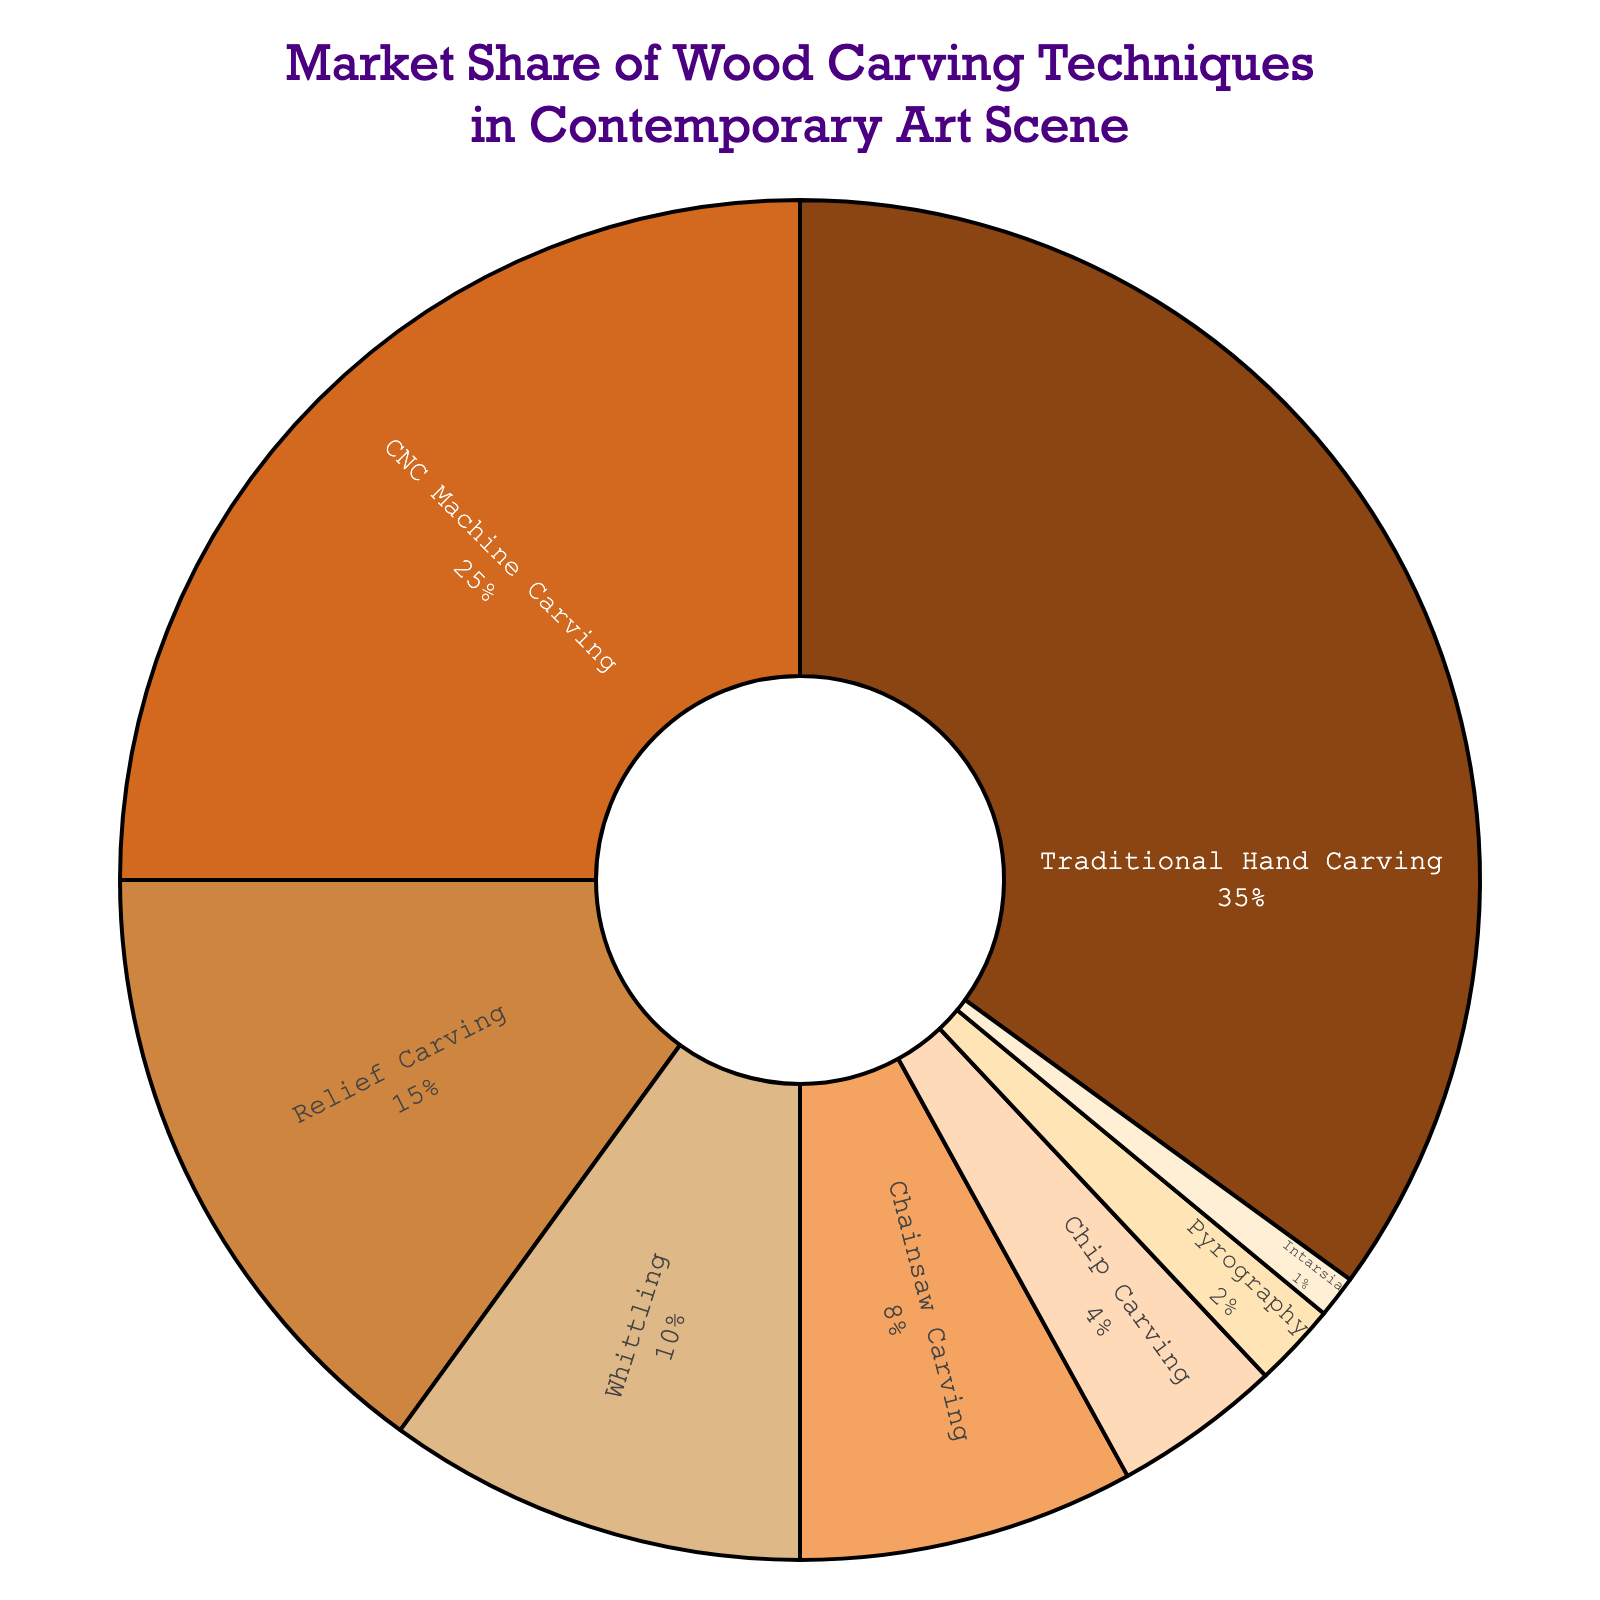How much market share do hand carving and relief carving techniques together hold? The market share of hand carving is 35%, and the market share of relief carving is 15%. By adding these percentages together, 35% + 15%, we find the combined market share.
Answer: 50% Which technique has a greater market share: chainsaw carving or chip carving? Chainsaw carving holds 8% of the market, while chip carving holds 4%. Comparing these percentages shows that chainsaw carving has a greater market share than chip carving.
Answer: Chainsaw carving What technique has the smallest market share and how much is it? The technique with the smallest market share is Intarsia, which holds 1% of the market.
Answer: Intarsia, 1% Which technique has the second-highest market share? The technique with the highest market share is Traditional Hand Carving with 35%. The technique with the second-highest market share is CNC Machine Carving with 25%.
Answer: CNC Machine Carving What is the combined market share of CNC Machine Carving and Whittling techniques? The market share of CNC Machine Carving is 25%, and the market share of Whittling is 10%. Adding these together gives 25% + 10%, which is the combined market share.
Answer: 35% What color visually represents Relief Carving on the pie chart? In the provided color data for the pie chart, Relief Carving is represented visually by the color '#DEB887', which translates to a light brown or beige color.
Answer: Light brown/Beige What is the difference in market share between the most popular and least popular techniques? The most popular technique is Traditional Hand Carving with 35%, and the least popular is Intarsia with 1%. The difference in market share is 35% - 1%.
Answer: 34% How many techniques have a market share of 10% or greater? The techniques with market shares of 10% or greater are Traditional Hand Carving (35%), CNC Machine Carving (25%), and Relief Carving (15%), and Whittling (10%). There are four techniques in total.
Answer: Four Which two techniques share the same color shading on the pie chart? By observing the color scheme of the pie chart, no two techniques share exactly the same color shading; each technique has a distinct color.
Answer: None 